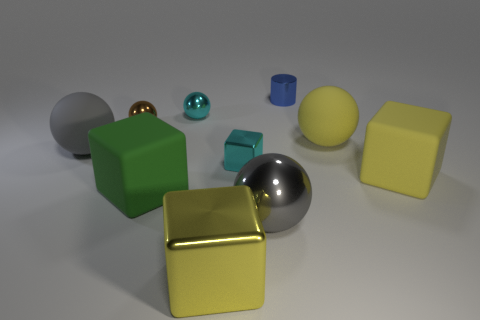How does the lighting affect how we perceive the textures of the objects? The lighting in the image casts subtle shadows and highlights that reveal the textures of the objects. For instance, the soft shadows under the cubes suggest a less reflective, matte surface, while the strong highlights on the metallic sphere and golden cube indicate highly reflective, glossy materials. Such lighting nuances contribute to the realism of the scene and our perception of the different material properties. 